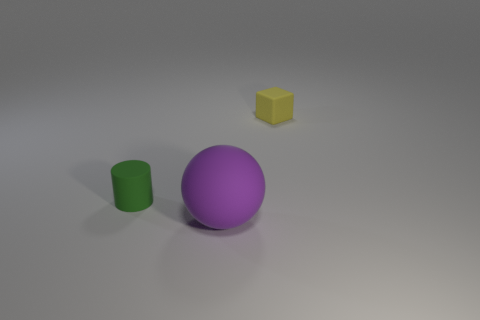There is a thing that is behind the purple matte thing and in front of the yellow object; what is it made of?
Your answer should be very brief. Rubber. What number of objects are matte cylinders or large blue cubes?
Your answer should be very brief. 1. How many large purple spheres have the same material as the small green cylinder?
Your answer should be very brief. 1. Are there fewer large purple rubber objects than small objects?
Your response must be concise. Yes. How many cylinders are either tiny green things or big purple rubber things?
Provide a succinct answer. 1. The matte object that is both on the left side of the yellow matte object and on the right side of the small green matte cylinder has what shape?
Give a very brief answer. Sphere. What is the color of the tiny object in front of the tiny object that is to the right of the tiny object that is to the left of the rubber ball?
Your answer should be compact. Green. Are there fewer rubber blocks left of the yellow object than tiny blocks?
Provide a succinct answer. Yes. How many things are tiny matte things in front of the matte block or purple rubber things?
Your answer should be compact. 2. Is there a large ball that is in front of the tiny object in front of the tiny thing to the right of the green cylinder?
Your answer should be compact. Yes. 